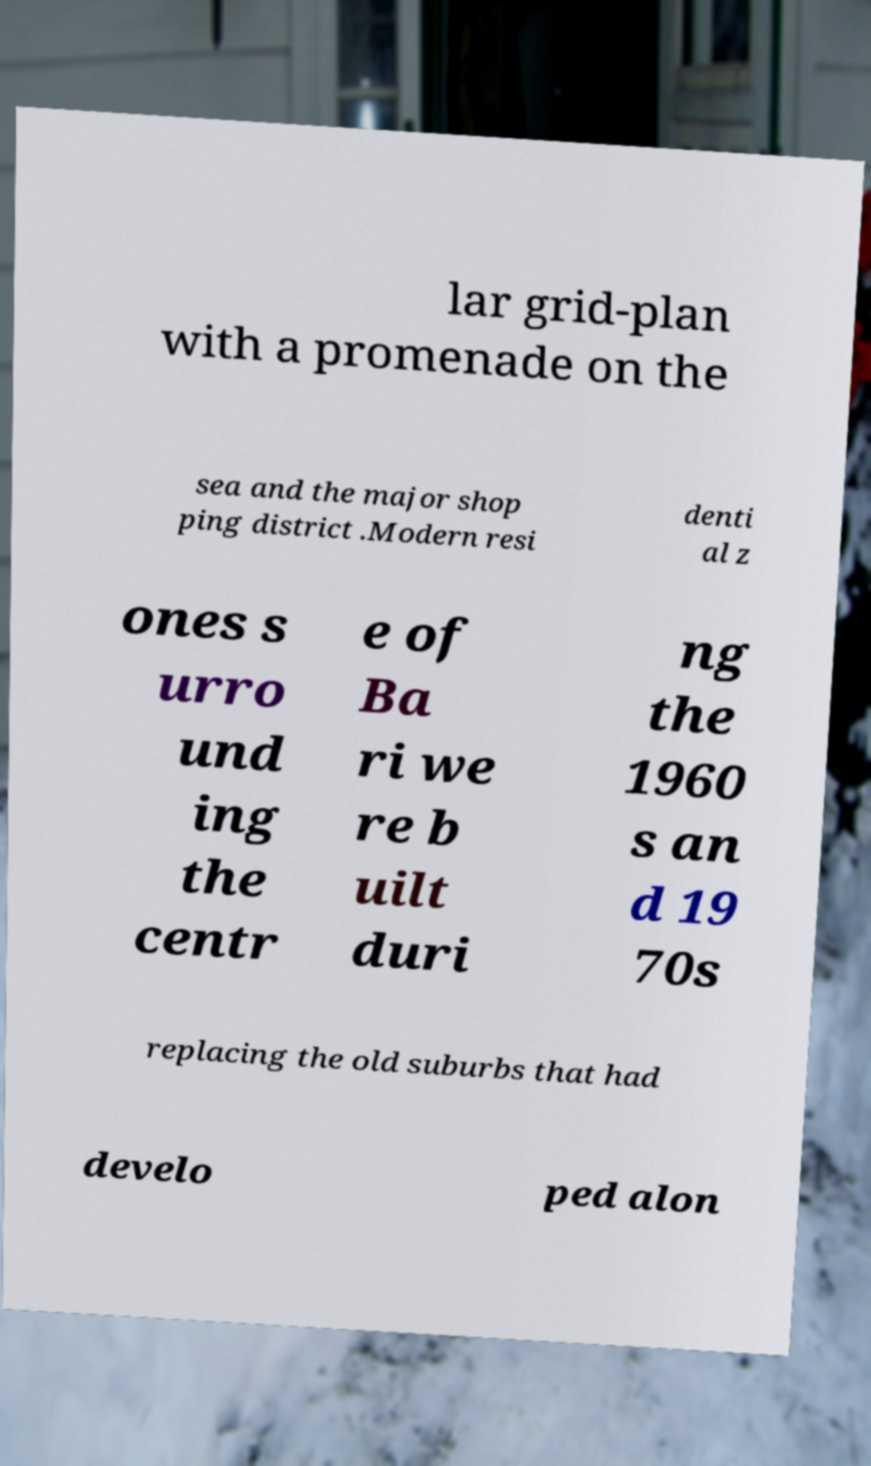For documentation purposes, I need the text within this image transcribed. Could you provide that? lar grid-plan with a promenade on the sea and the major shop ping district .Modern resi denti al z ones s urro und ing the centr e of Ba ri we re b uilt duri ng the 1960 s an d 19 70s replacing the old suburbs that had develo ped alon 